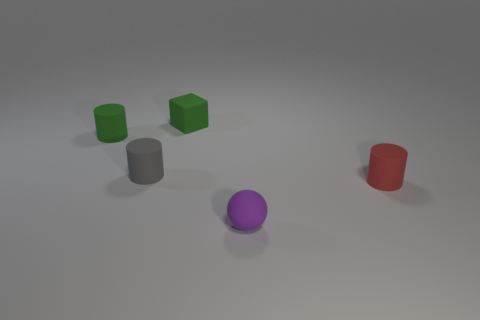Add 5 small matte balls. How many objects exist? 10 Subtract all cylinders. How many objects are left? 2 Add 5 tiny purple spheres. How many tiny purple spheres are left? 6 Add 3 red rubber cylinders. How many red rubber cylinders exist? 4 Subtract 0 gray spheres. How many objects are left? 5 Subtract all red rubber cylinders. Subtract all tiny red matte cylinders. How many objects are left? 3 